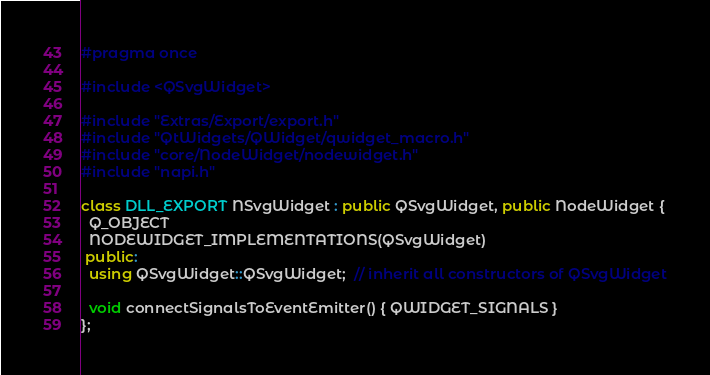Convert code to text. <code><loc_0><loc_0><loc_500><loc_500><_C++_>#pragma once

#include <QSvgWidget>

#include "Extras/Export/export.h"
#include "QtWidgets/QWidget/qwidget_macro.h"
#include "core/NodeWidget/nodewidget.h"
#include "napi.h"

class DLL_EXPORT NSvgWidget : public QSvgWidget, public NodeWidget {
  Q_OBJECT
  NODEWIDGET_IMPLEMENTATIONS(QSvgWidget)
 public:
  using QSvgWidget::QSvgWidget;  // inherit all constructors of QSvgWidget

  void connectSignalsToEventEmitter() { QWIDGET_SIGNALS }
};
</code> 